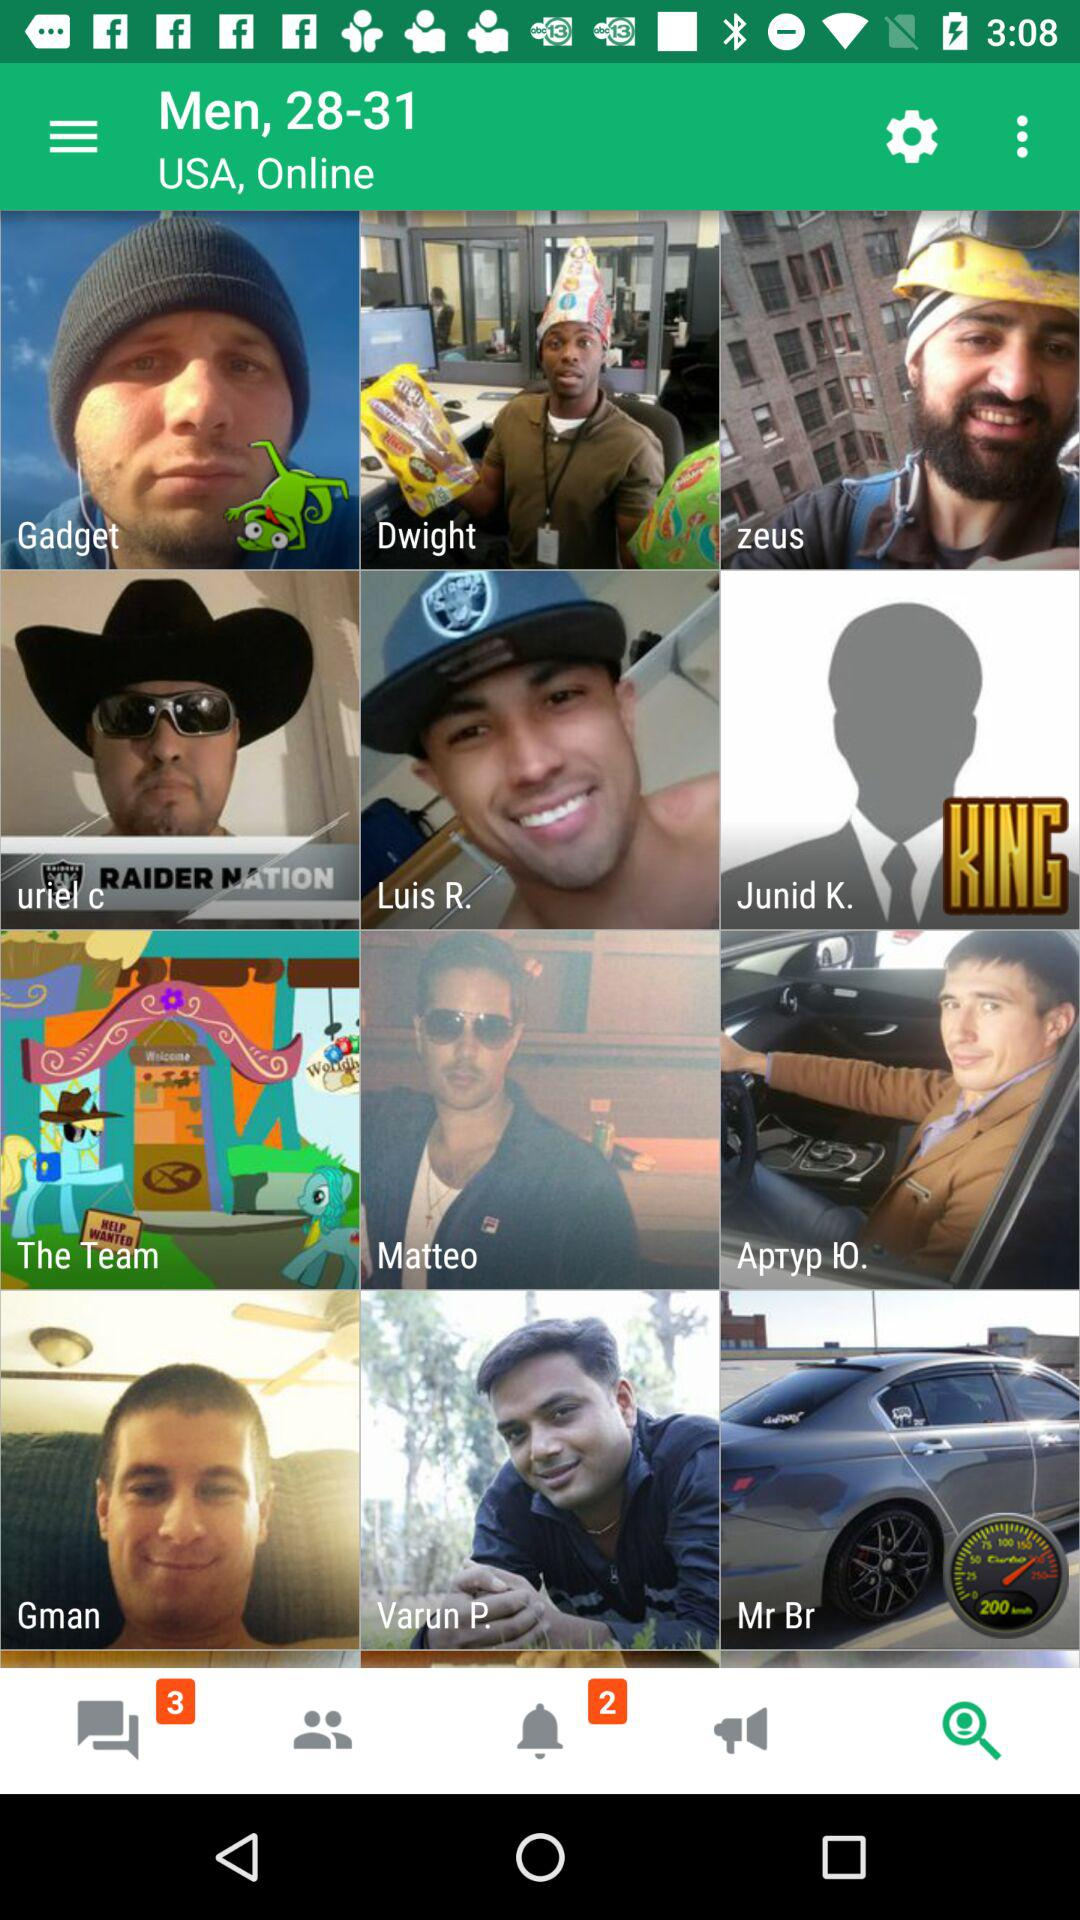What is the location? The location is "USA". 